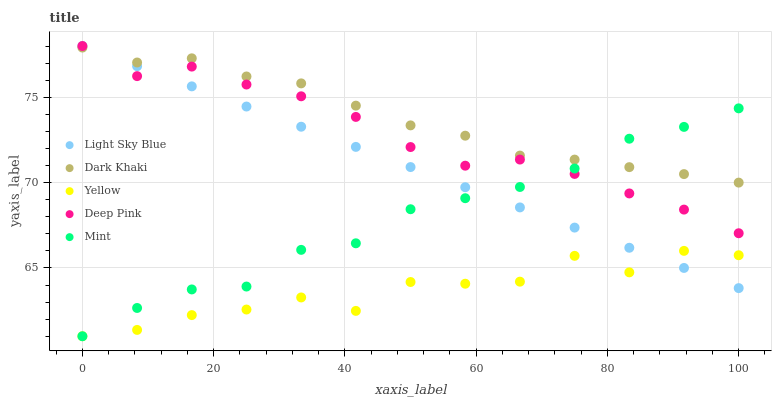Does Yellow have the minimum area under the curve?
Answer yes or no. Yes. Does Dark Khaki have the maximum area under the curve?
Answer yes or no. Yes. Does Light Sky Blue have the minimum area under the curve?
Answer yes or no. No. Does Light Sky Blue have the maximum area under the curve?
Answer yes or no. No. Is Light Sky Blue the smoothest?
Answer yes or no. Yes. Is Yellow the roughest?
Answer yes or no. Yes. Is Mint the smoothest?
Answer yes or no. No. Is Mint the roughest?
Answer yes or no. No. Does Mint have the lowest value?
Answer yes or no. Yes. Does Light Sky Blue have the lowest value?
Answer yes or no. No. Does Deep Pink have the highest value?
Answer yes or no. Yes. Does Mint have the highest value?
Answer yes or no. No. Is Yellow less than Dark Khaki?
Answer yes or no. Yes. Is Dark Khaki greater than Yellow?
Answer yes or no. Yes. Does Deep Pink intersect Mint?
Answer yes or no. Yes. Is Deep Pink less than Mint?
Answer yes or no. No. Is Deep Pink greater than Mint?
Answer yes or no. No. Does Yellow intersect Dark Khaki?
Answer yes or no. No. 